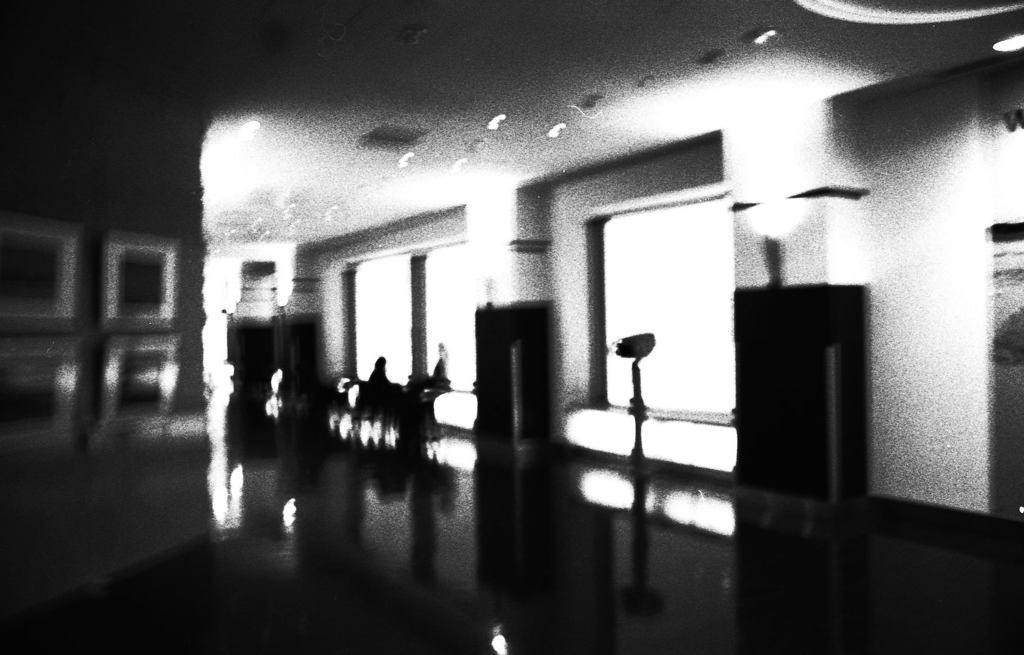What is the color scheme of the image? The image is black and white. Where was the image taken? The image was taken in a room. What can be seen through the windows in the room? The presence of windows in the room suggests that there might be a view outside, but the specifics are not mentioned in the facts. What is the person in the image doing? There is a person sitting on a bench in the room. What is visible on the floor in the room? The floor is visible in the room, but the specifics of what is on the floor are not mentioned in the facts. What type of furniture is present in the room? There are cupboards in the room. Can you see the mitten being used to apply the brake in the image? There is no mitten or brake present in the image. What type of whistle can be heard in the background of the image? There is no whistle or sound mentioned in the image, as it is a still photograph. 